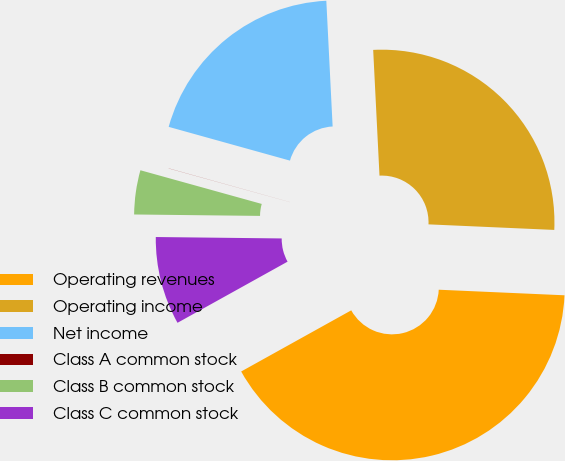Convert chart. <chart><loc_0><loc_0><loc_500><loc_500><pie_chart><fcel>Operating revenues<fcel>Operating income<fcel>Net income<fcel>Class A common stock<fcel>Class B common stock<fcel>Class C common stock<nl><fcel>41.22%<fcel>26.5%<fcel>19.88%<fcel>0.01%<fcel>4.13%<fcel>8.25%<nl></chart> 